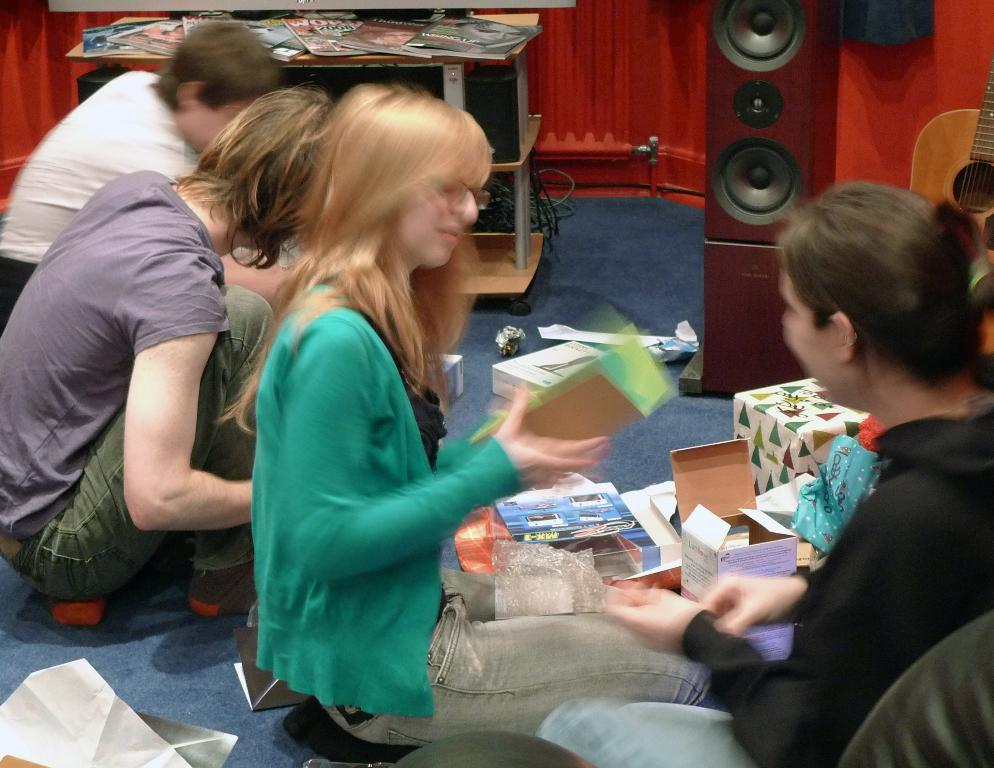In one or two sentences, can you explain what this image depicts? In this image we can see people. The person sitting in the center is holding a card. There are some things placed on the carpet. In the background there is a table and we can see books placed on the table. There is a speaker. On the right we can see a guitar and there is a wall. 